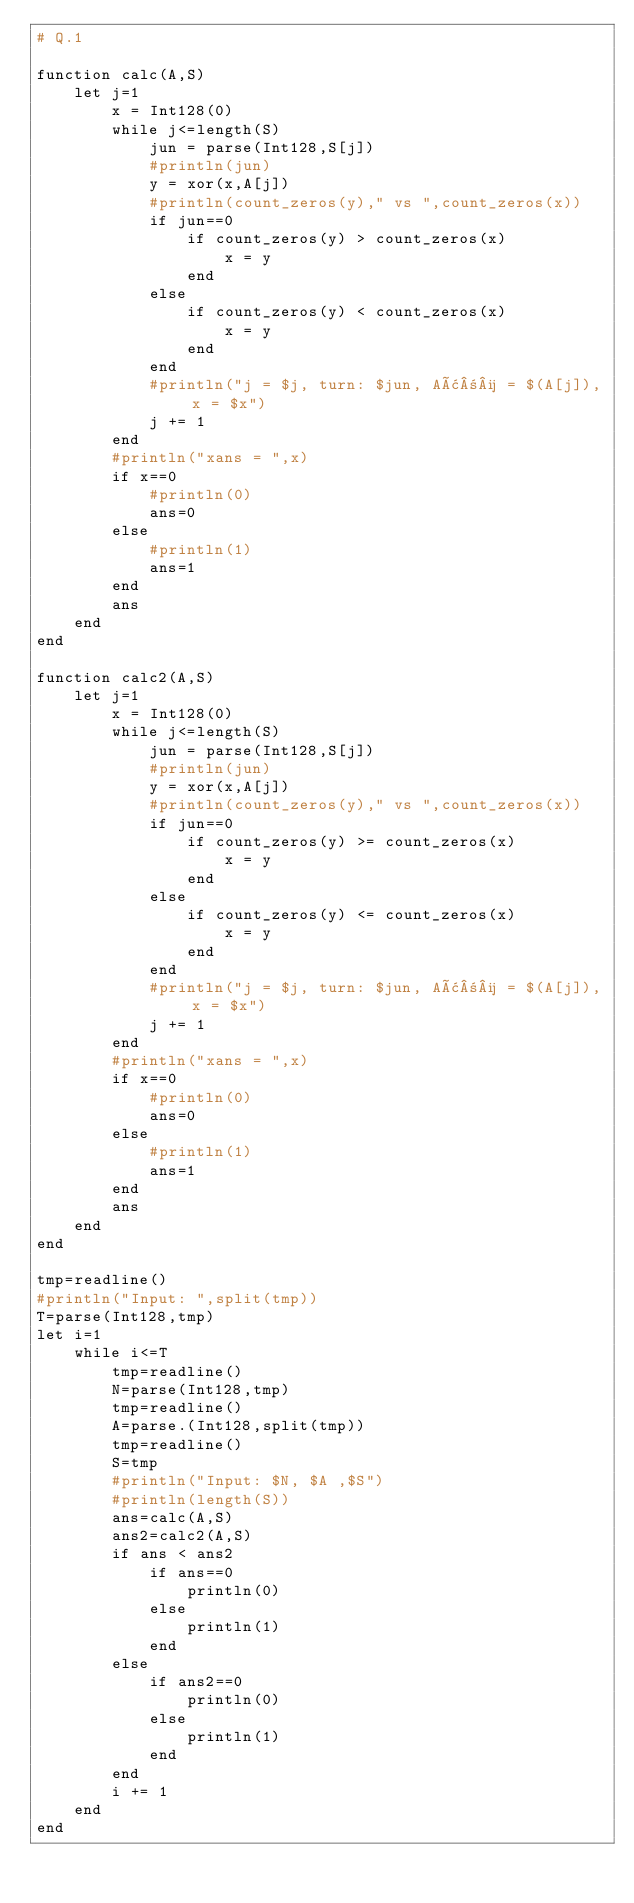Convert code to text. <code><loc_0><loc_0><loc_500><loc_500><_Julia_># Q.1

function calc(A,S)
    let j=1
        x = Int128(0)
        while j<=length(S)
            jun = parse(Int128,S[j])
            #println(jun)
            y = xor(x,A[j])
            #println(count_zeros(y)," vs ",count_zeros(x))
            if jun==0
                if count_zeros(y) > count_zeros(x)
                    x = y
                end
            else
                if count_zeros(y) < count_zeros(x)
                    x = y
                end
            end
            #println("j = $j, turn: $jun, Aâ±¼ = $(A[j]), x = $x")
            j += 1
        end
        #println("xans = ",x)
        if x==0
            #println(0)
            ans=0
        else
            #println(1)
            ans=1
        end
        ans
    end
end

function calc2(A,S)
    let j=1
        x = Int128(0)
        while j<=length(S)
            jun = parse(Int128,S[j])
            #println(jun)
            y = xor(x,A[j])
            #println(count_zeros(y)," vs ",count_zeros(x))
            if jun==0
                if count_zeros(y) >= count_zeros(x)
                    x = y
                end
            else
                if count_zeros(y) <= count_zeros(x)
                    x = y
                end
            end
            #println("j = $j, turn: $jun, Aâ±¼ = $(A[j]), x = $x")
            j += 1
        end
        #println("xans = ",x)
        if x==0
            #println(0)
            ans=0
        else
            #println(1)
            ans=1
        end
        ans
    end
end

tmp=readline()
#println("Input: ",split(tmp))
T=parse(Int128,tmp)
let i=1
    while i<=T
        tmp=readline()
        N=parse(Int128,tmp)
        tmp=readline()
        A=parse.(Int128,split(tmp))
        tmp=readline()
        S=tmp
        #println("Input: $N, $A ,$S")
        #println(length(S))
        ans=calc(A,S)
        ans2=calc2(A,S)
        if ans < ans2
            if ans==0
                println(0)
            else
                println(1)
            end
        else
            if ans2==0
                println(0)
            else
                println(1)
            end
        end
        i += 1
    end
end
</code> 